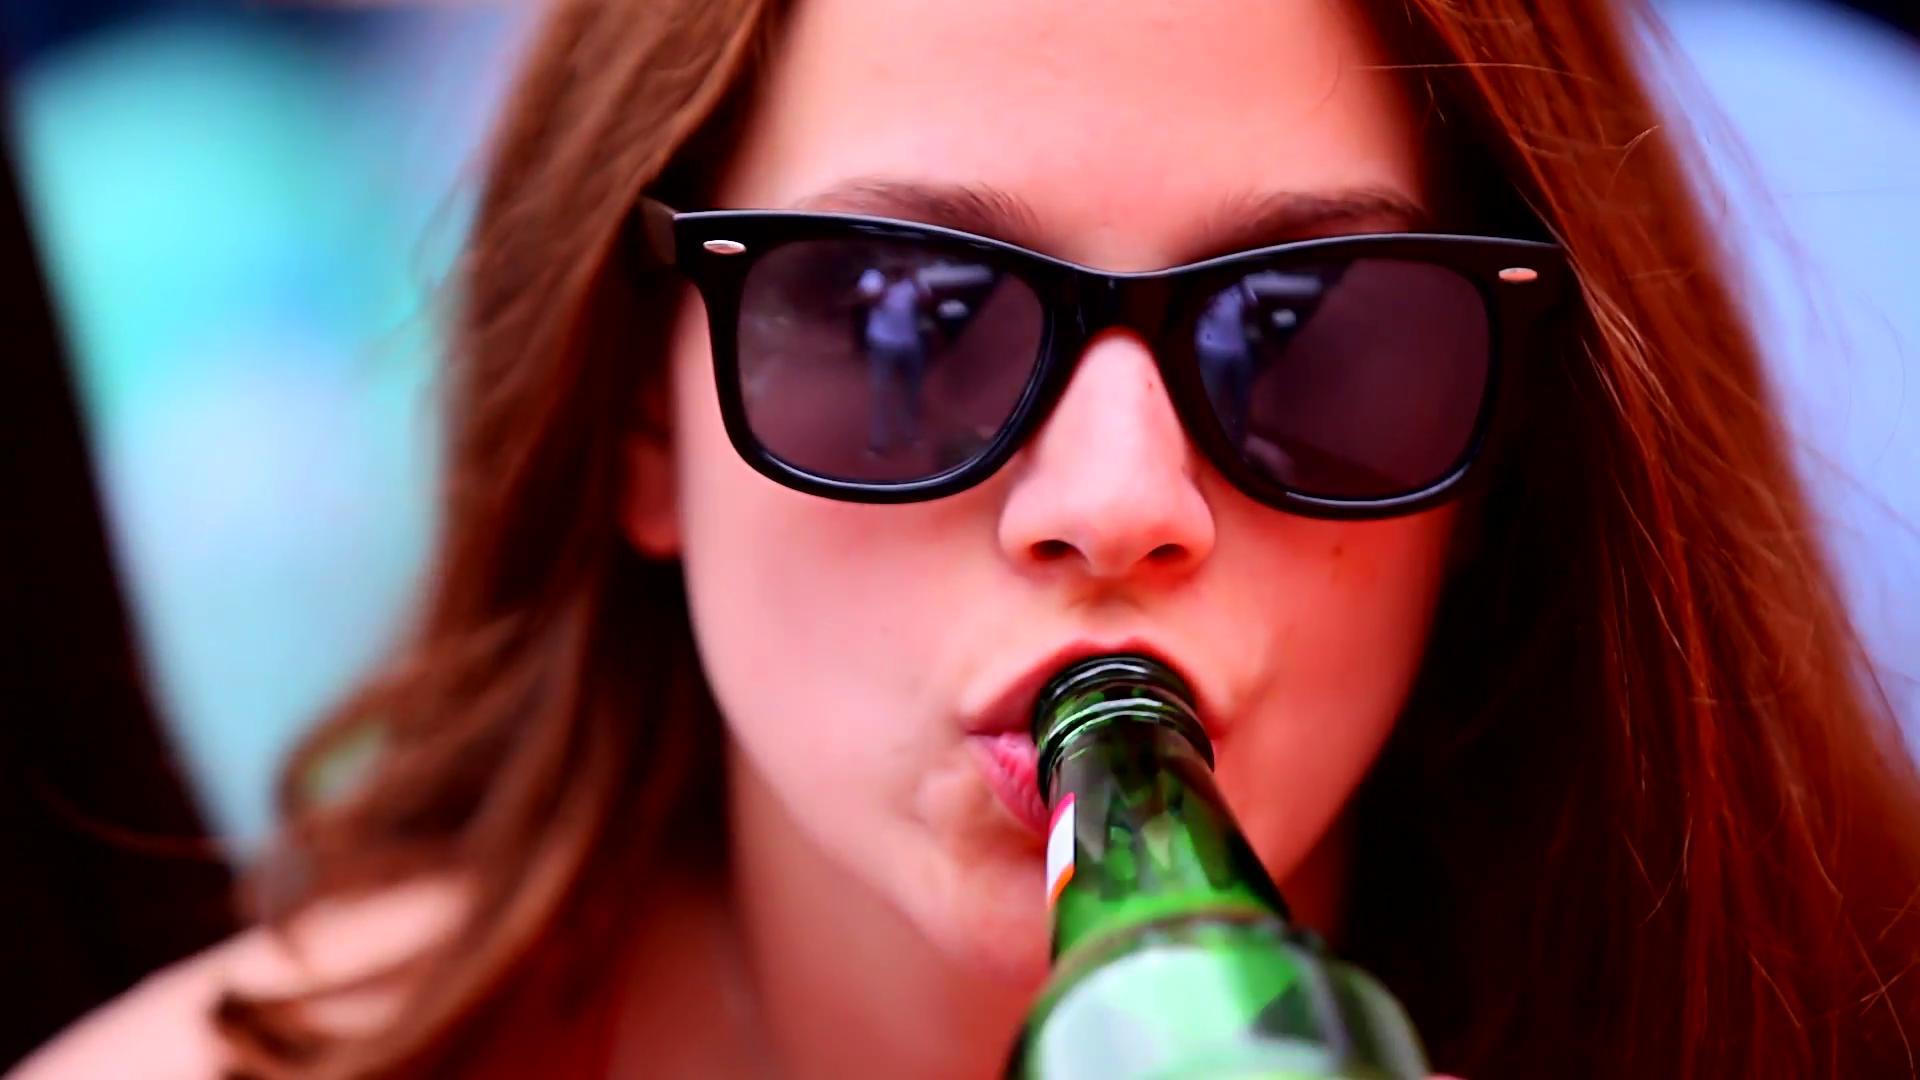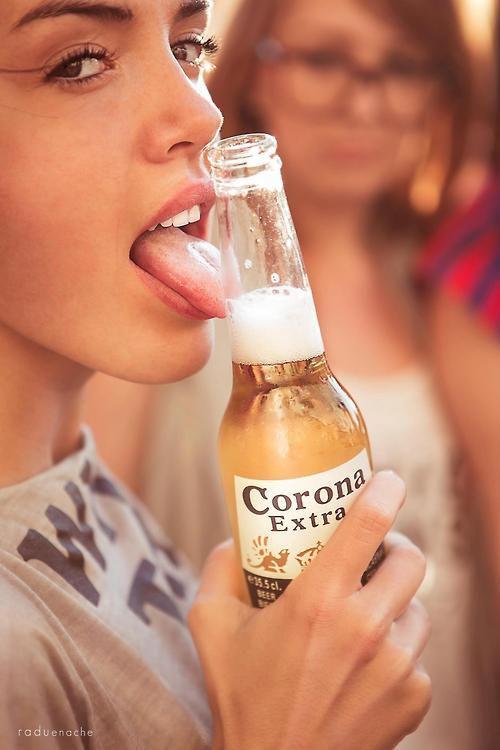The first image is the image on the left, the second image is the image on the right. Considering the images on both sides, is "The woman in the image on the right is lifting a green bottle to her mouth." valid? Answer yes or no. No. 